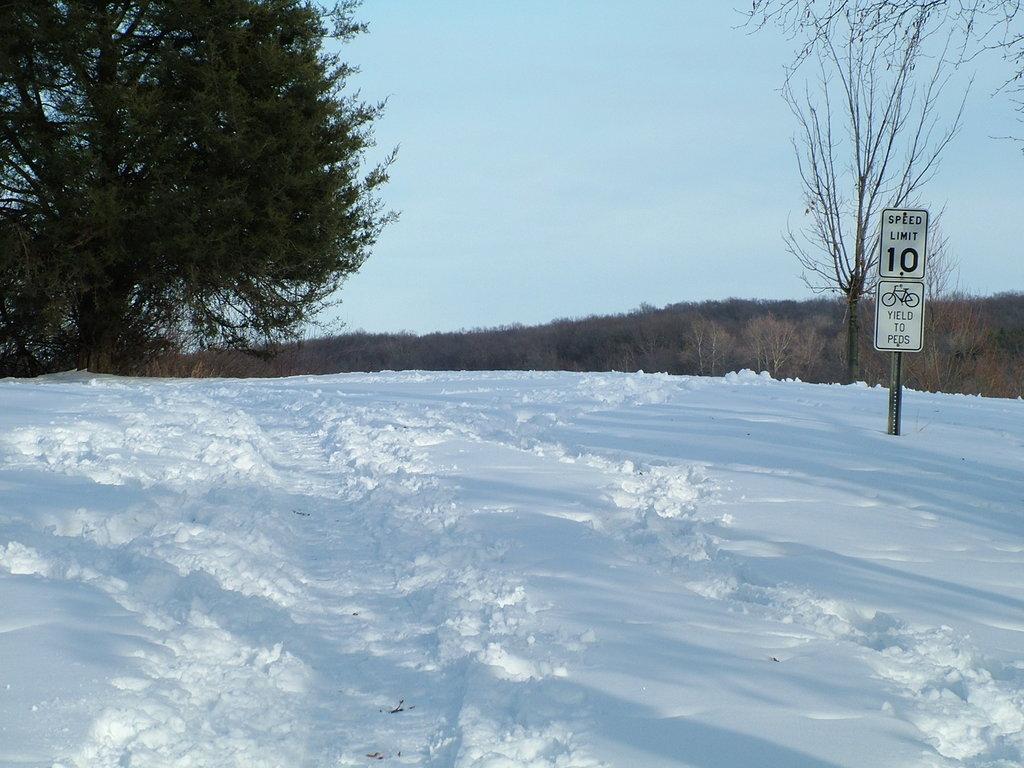Can you describe this image briefly? In this picture we can see snow at the bottom, in the background there are some trees, we can see a board where, there is the sky at the top of the picture. 